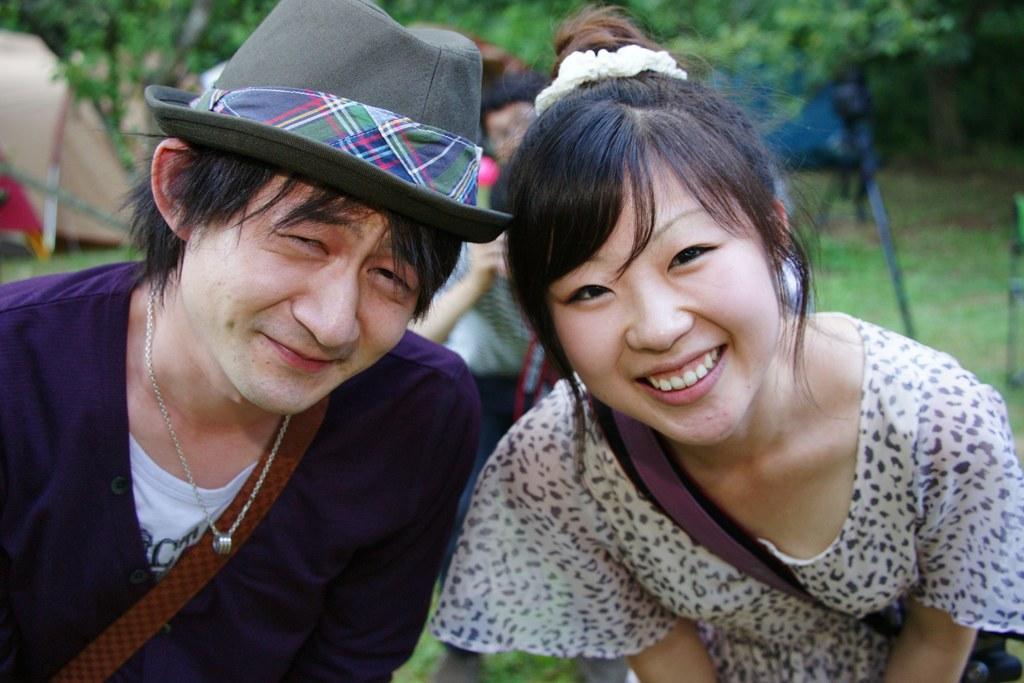In one or two sentences, can you explain what this image depicts? In this picture we can see a man and a woman standing and smiling. There is a person holding an object. We can see a few leaves and other objects in the background. 